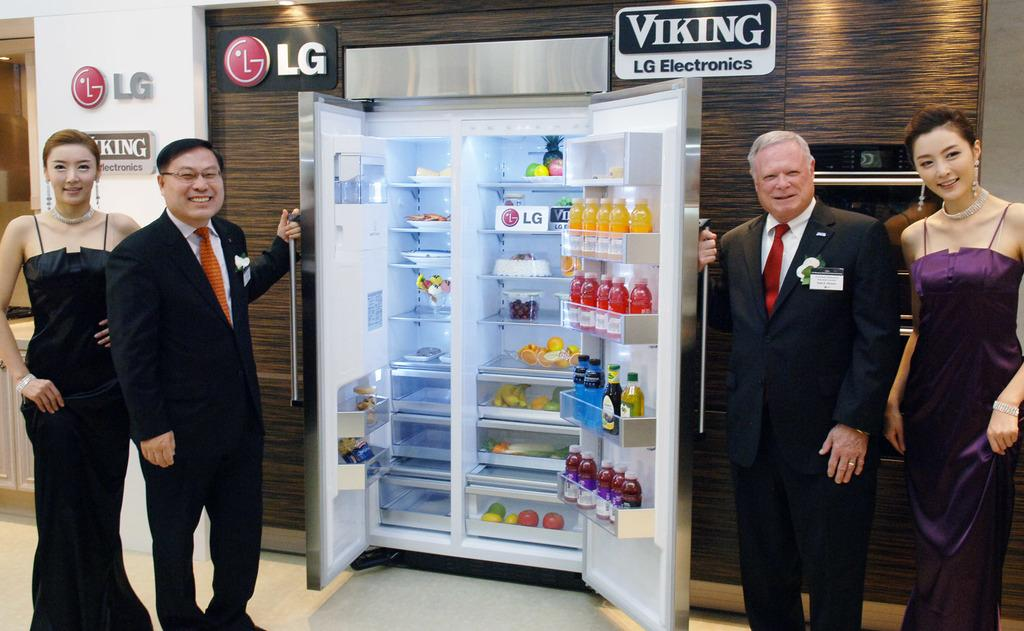<image>
Share a concise interpretation of the image provided. four people standing in front of an open fridge with a sign for LG in it 